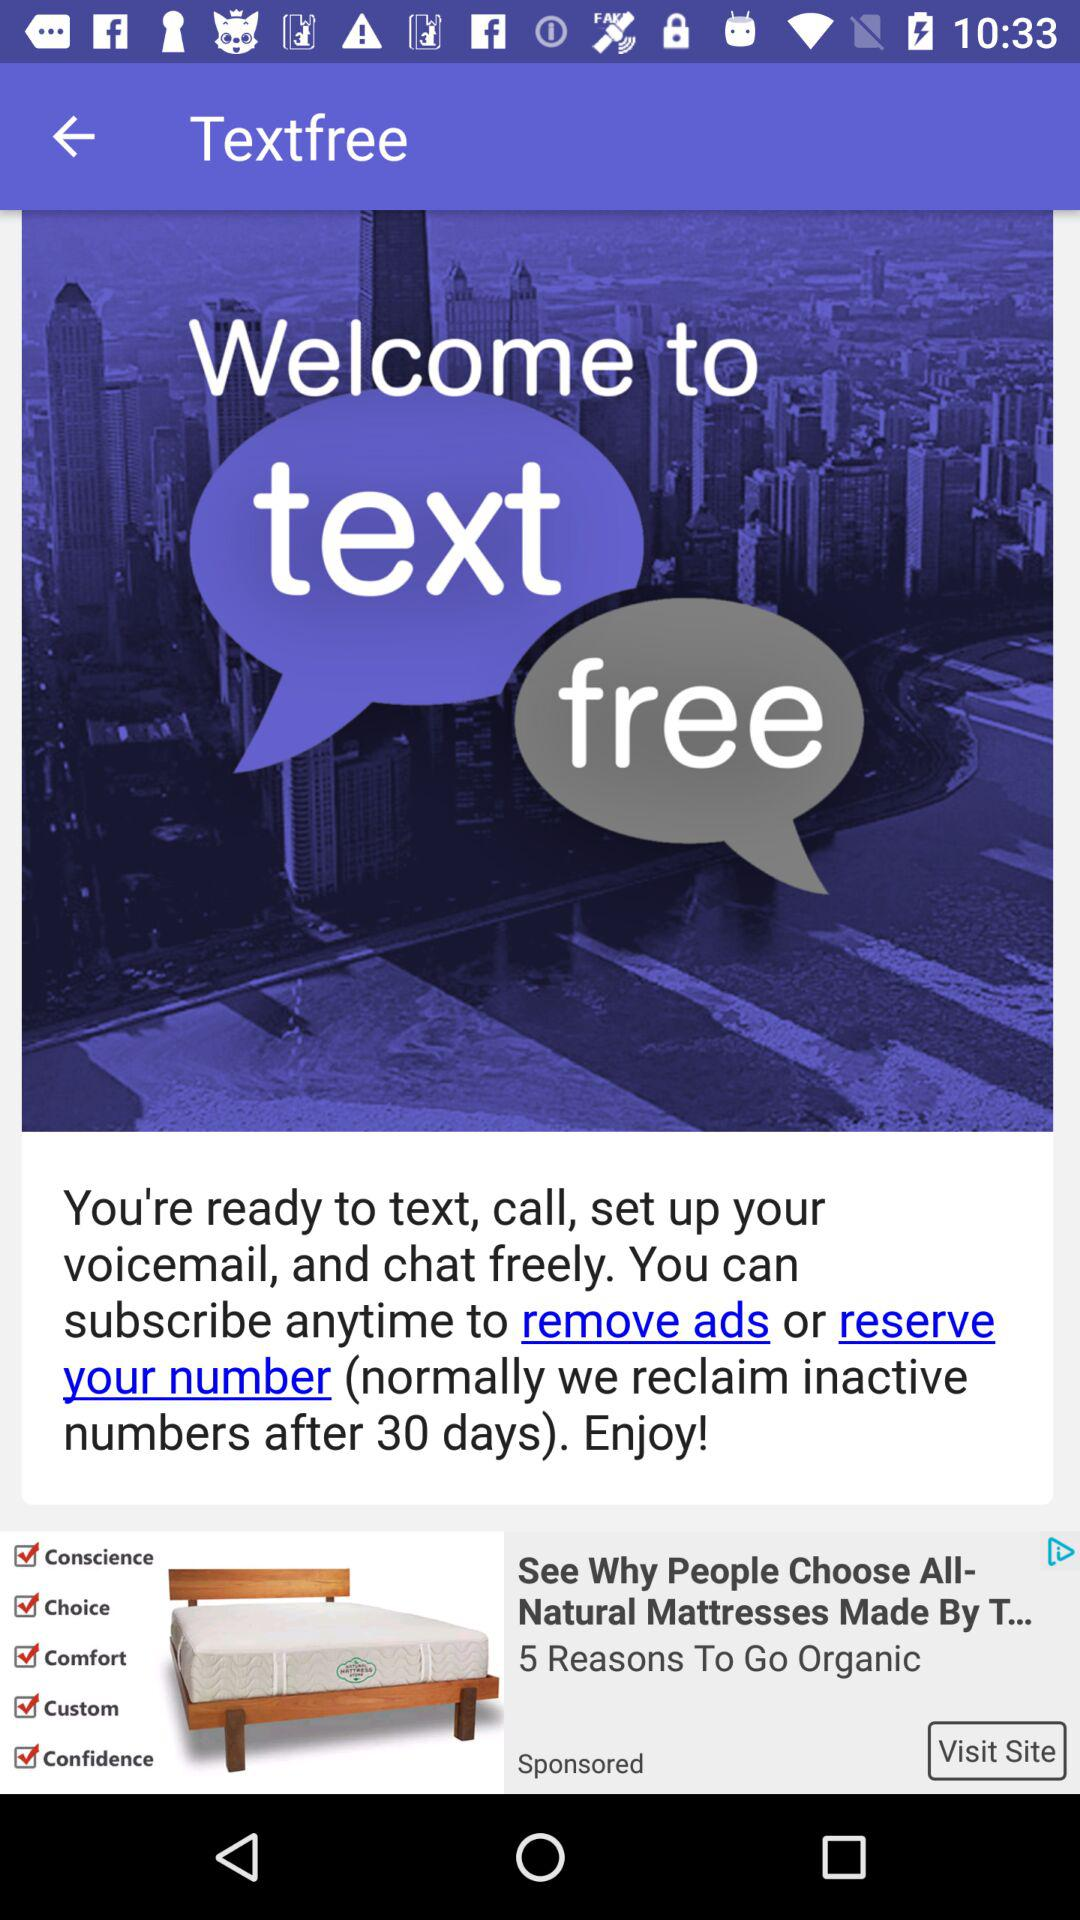What is the application name? The application name is "Textfree". 